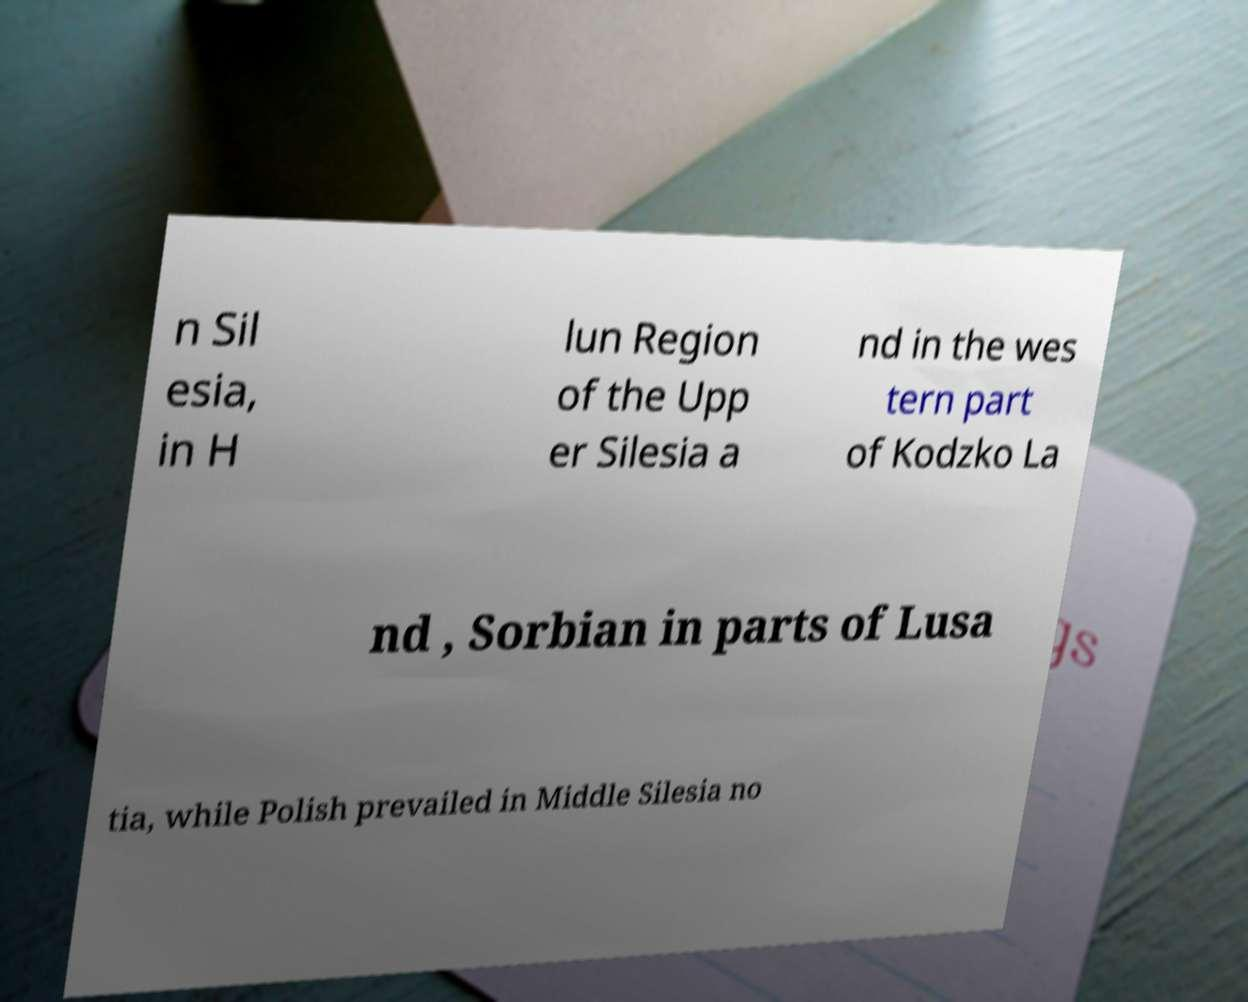I need the written content from this picture converted into text. Can you do that? n Sil esia, in H lun Region of the Upp er Silesia a nd in the wes tern part of Kodzko La nd , Sorbian in parts of Lusa tia, while Polish prevailed in Middle Silesia no 